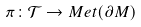<formula> <loc_0><loc_0><loc_500><loc_500>\pi \colon { \mathcal { T } } \rightarrow M e t ( \partial M )</formula> 